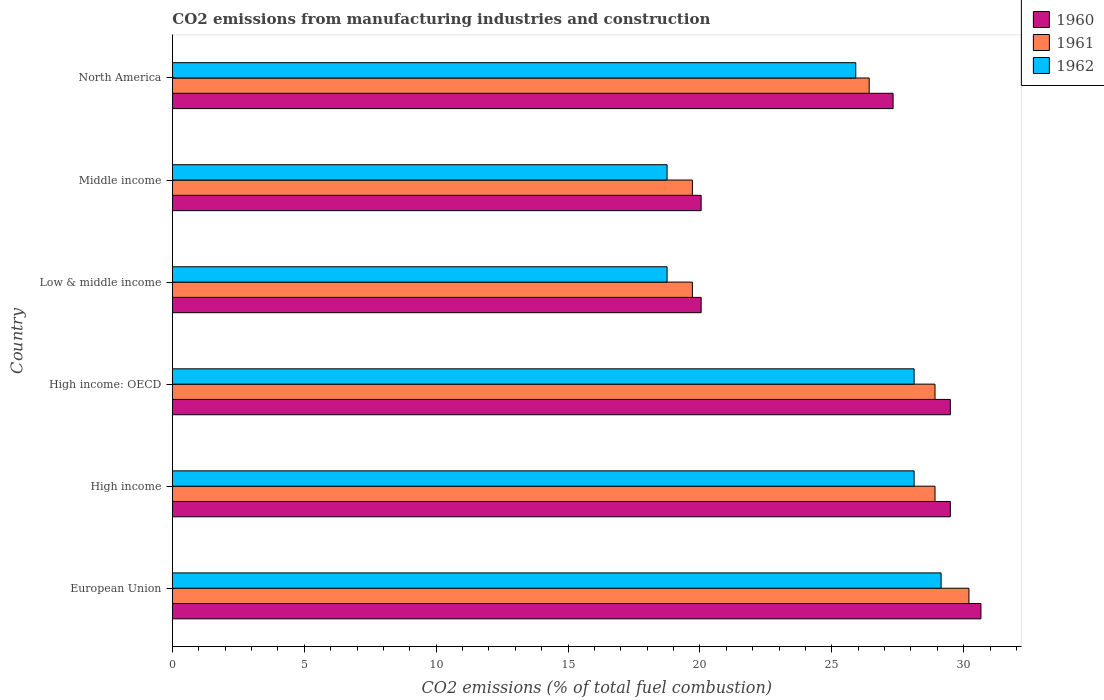How many groups of bars are there?
Provide a succinct answer. 6. Are the number of bars per tick equal to the number of legend labels?
Offer a very short reply. Yes. Are the number of bars on each tick of the Y-axis equal?
Ensure brevity in your answer.  Yes. How many bars are there on the 2nd tick from the top?
Offer a terse response. 3. How many bars are there on the 1st tick from the bottom?
Ensure brevity in your answer.  3. What is the label of the 3rd group of bars from the top?
Provide a succinct answer. Low & middle income. What is the amount of CO2 emitted in 1961 in High income: OECD?
Provide a succinct answer. 28.92. Across all countries, what is the maximum amount of CO2 emitted in 1960?
Make the answer very short. 30.66. Across all countries, what is the minimum amount of CO2 emitted in 1960?
Keep it short and to the point. 20.05. In which country was the amount of CO2 emitted in 1960 maximum?
Your response must be concise. European Union. What is the total amount of CO2 emitted in 1960 in the graph?
Your answer should be very brief. 157.07. What is the difference between the amount of CO2 emitted in 1961 in European Union and that in High income?
Provide a short and direct response. 1.29. What is the difference between the amount of CO2 emitted in 1962 in Middle income and the amount of CO2 emitted in 1961 in Low & middle income?
Offer a very short reply. -0.96. What is the average amount of CO2 emitted in 1962 per country?
Provide a succinct answer. 24.8. What is the difference between the amount of CO2 emitted in 1961 and amount of CO2 emitted in 1960 in Middle income?
Provide a short and direct response. -0.33. In how many countries, is the amount of CO2 emitted in 1960 greater than 4 %?
Ensure brevity in your answer.  6. What is the ratio of the amount of CO2 emitted in 1961 in High income: OECD to that in Low & middle income?
Make the answer very short. 1.47. Is the amount of CO2 emitted in 1961 in High income less than that in High income: OECD?
Your answer should be very brief. No. What is the difference between the highest and the second highest amount of CO2 emitted in 1962?
Give a very brief answer. 1.02. What is the difference between the highest and the lowest amount of CO2 emitted in 1960?
Offer a terse response. 10.61. Are all the bars in the graph horizontal?
Provide a short and direct response. Yes. Are the values on the major ticks of X-axis written in scientific E-notation?
Offer a very short reply. No. Does the graph contain any zero values?
Ensure brevity in your answer.  No. Does the graph contain grids?
Give a very brief answer. No. What is the title of the graph?
Make the answer very short. CO2 emissions from manufacturing industries and construction. What is the label or title of the X-axis?
Keep it short and to the point. CO2 emissions (% of total fuel combustion). What is the label or title of the Y-axis?
Your answer should be compact. Country. What is the CO2 emissions (% of total fuel combustion) of 1960 in European Union?
Keep it short and to the point. 30.66. What is the CO2 emissions (% of total fuel combustion) of 1961 in European Union?
Your answer should be compact. 30.2. What is the CO2 emissions (% of total fuel combustion) of 1962 in European Union?
Keep it short and to the point. 29.15. What is the CO2 emissions (% of total fuel combustion) of 1960 in High income?
Make the answer very short. 29.5. What is the CO2 emissions (% of total fuel combustion) in 1961 in High income?
Provide a short and direct response. 28.92. What is the CO2 emissions (% of total fuel combustion) of 1962 in High income?
Provide a short and direct response. 28.12. What is the CO2 emissions (% of total fuel combustion) in 1960 in High income: OECD?
Ensure brevity in your answer.  29.5. What is the CO2 emissions (% of total fuel combustion) of 1961 in High income: OECD?
Provide a short and direct response. 28.92. What is the CO2 emissions (% of total fuel combustion) of 1962 in High income: OECD?
Your answer should be compact. 28.12. What is the CO2 emissions (% of total fuel combustion) of 1960 in Low & middle income?
Give a very brief answer. 20.05. What is the CO2 emissions (% of total fuel combustion) of 1961 in Low & middle income?
Offer a terse response. 19.72. What is the CO2 emissions (% of total fuel combustion) in 1962 in Low & middle income?
Give a very brief answer. 18.76. What is the CO2 emissions (% of total fuel combustion) of 1960 in Middle income?
Provide a succinct answer. 20.05. What is the CO2 emissions (% of total fuel combustion) in 1961 in Middle income?
Provide a succinct answer. 19.72. What is the CO2 emissions (% of total fuel combustion) in 1962 in Middle income?
Your answer should be very brief. 18.76. What is the CO2 emissions (% of total fuel combustion) of 1960 in North America?
Offer a very short reply. 27.33. What is the CO2 emissions (% of total fuel combustion) of 1961 in North America?
Your response must be concise. 26.42. What is the CO2 emissions (% of total fuel combustion) in 1962 in North America?
Offer a terse response. 25.91. Across all countries, what is the maximum CO2 emissions (% of total fuel combustion) in 1960?
Your response must be concise. 30.66. Across all countries, what is the maximum CO2 emissions (% of total fuel combustion) in 1961?
Provide a succinct answer. 30.2. Across all countries, what is the maximum CO2 emissions (% of total fuel combustion) in 1962?
Your answer should be very brief. 29.15. Across all countries, what is the minimum CO2 emissions (% of total fuel combustion) in 1960?
Provide a succinct answer. 20.05. Across all countries, what is the minimum CO2 emissions (% of total fuel combustion) in 1961?
Keep it short and to the point. 19.72. Across all countries, what is the minimum CO2 emissions (% of total fuel combustion) of 1962?
Ensure brevity in your answer.  18.76. What is the total CO2 emissions (% of total fuel combustion) of 1960 in the graph?
Provide a short and direct response. 157.07. What is the total CO2 emissions (% of total fuel combustion) in 1961 in the graph?
Provide a short and direct response. 153.88. What is the total CO2 emissions (% of total fuel combustion) in 1962 in the graph?
Your response must be concise. 148.82. What is the difference between the CO2 emissions (% of total fuel combustion) of 1960 in European Union and that in High income?
Provide a short and direct response. 1.16. What is the difference between the CO2 emissions (% of total fuel combustion) in 1961 in European Union and that in High income?
Make the answer very short. 1.29. What is the difference between the CO2 emissions (% of total fuel combustion) in 1962 in European Union and that in High income?
Give a very brief answer. 1.02. What is the difference between the CO2 emissions (% of total fuel combustion) in 1960 in European Union and that in High income: OECD?
Make the answer very short. 1.16. What is the difference between the CO2 emissions (% of total fuel combustion) in 1961 in European Union and that in High income: OECD?
Keep it short and to the point. 1.29. What is the difference between the CO2 emissions (% of total fuel combustion) in 1962 in European Union and that in High income: OECD?
Your answer should be very brief. 1.02. What is the difference between the CO2 emissions (% of total fuel combustion) in 1960 in European Union and that in Low & middle income?
Offer a terse response. 10.61. What is the difference between the CO2 emissions (% of total fuel combustion) of 1961 in European Union and that in Low & middle income?
Your response must be concise. 10.48. What is the difference between the CO2 emissions (% of total fuel combustion) in 1962 in European Union and that in Low & middle income?
Ensure brevity in your answer.  10.39. What is the difference between the CO2 emissions (% of total fuel combustion) in 1960 in European Union and that in Middle income?
Your response must be concise. 10.61. What is the difference between the CO2 emissions (% of total fuel combustion) of 1961 in European Union and that in Middle income?
Your response must be concise. 10.48. What is the difference between the CO2 emissions (% of total fuel combustion) of 1962 in European Union and that in Middle income?
Your response must be concise. 10.39. What is the difference between the CO2 emissions (% of total fuel combustion) in 1960 in European Union and that in North America?
Offer a very short reply. 3.33. What is the difference between the CO2 emissions (% of total fuel combustion) in 1961 in European Union and that in North America?
Your response must be concise. 3.78. What is the difference between the CO2 emissions (% of total fuel combustion) of 1962 in European Union and that in North America?
Make the answer very short. 3.24. What is the difference between the CO2 emissions (% of total fuel combustion) of 1961 in High income and that in High income: OECD?
Give a very brief answer. 0. What is the difference between the CO2 emissions (% of total fuel combustion) in 1960 in High income and that in Low & middle income?
Your response must be concise. 9.45. What is the difference between the CO2 emissions (% of total fuel combustion) in 1961 in High income and that in Low & middle income?
Your answer should be very brief. 9.2. What is the difference between the CO2 emissions (% of total fuel combustion) in 1962 in High income and that in Low & middle income?
Your answer should be compact. 9.37. What is the difference between the CO2 emissions (% of total fuel combustion) of 1960 in High income and that in Middle income?
Keep it short and to the point. 9.45. What is the difference between the CO2 emissions (% of total fuel combustion) in 1961 in High income and that in Middle income?
Your answer should be very brief. 9.2. What is the difference between the CO2 emissions (% of total fuel combustion) of 1962 in High income and that in Middle income?
Your answer should be very brief. 9.37. What is the difference between the CO2 emissions (% of total fuel combustion) of 1960 in High income and that in North America?
Make the answer very short. 2.17. What is the difference between the CO2 emissions (% of total fuel combustion) of 1961 in High income and that in North America?
Your answer should be very brief. 2.5. What is the difference between the CO2 emissions (% of total fuel combustion) of 1962 in High income and that in North America?
Give a very brief answer. 2.21. What is the difference between the CO2 emissions (% of total fuel combustion) of 1960 in High income: OECD and that in Low & middle income?
Provide a succinct answer. 9.45. What is the difference between the CO2 emissions (% of total fuel combustion) of 1961 in High income: OECD and that in Low & middle income?
Make the answer very short. 9.2. What is the difference between the CO2 emissions (% of total fuel combustion) in 1962 in High income: OECD and that in Low & middle income?
Your answer should be very brief. 9.37. What is the difference between the CO2 emissions (% of total fuel combustion) of 1960 in High income: OECD and that in Middle income?
Provide a succinct answer. 9.45. What is the difference between the CO2 emissions (% of total fuel combustion) of 1961 in High income: OECD and that in Middle income?
Ensure brevity in your answer.  9.2. What is the difference between the CO2 emissions (% of total fuel combustion) of 1962 in High income: OECD and that in Middle income?
Make the answer very short. 9.37. What is the difference between the CO2 emissions (% of total fuel combustion) in 1960 in High income: OECD and that in North America?
Offer a very short reply. 2.17. What is the difference between the CO2 emissions (% of total fuel combustion) of 1961 in High income: OECD and that in North America?
Provide a short and direct response. 2.5. What is the difference between the CO2 emissions (% of total fuel combustion) of 1962 in High income: OECD and that in North America?
Make the answer very short. 2.21. What is the difference between the CO2 emissions (% of total fuel combustion) in 1960 in Low & middle income and that in Middle income?
Ensure brevity in your answer.  0. What is the difference between the CO2 emissions (% of total fuel combustion) of 1960 in Low & middle income and that in North America?
Provide a succinct answer. -7.28. What is the difference between the CO2 emissions (% of total fuel combustion) of 1961 in Low & middle income and that in North America?
Provide a short and direct response. -6.7. What is the difference between the CO2 emissions (% of total fuel combustion) of 1962 in Low & middle income and that in North America?
Your response must be concise. -7.15. What is the difference between the CO2 emissions (% of total fuel combustion) in 1960 in Middle income and that in North America?
Offer a very short reply. -7.28. What is the difference between the CO2 emissions (% of total fuel combustion) in 1961 in Middle income and that in North America?
Offer a very short reply. -6.7. What is the difference between the CO2 emissions (% of total fuel combustion) of 1962 in Middle income and that in North America?
Keep it short and to the point. -7.15. What is the difference between the CO2 emissions (% of total fuel combustion) of 1960 in European Union and the CO2 emissions (% of total fuel combustion) of 1961 in High income?
Offer a terse response. 1.74. What is the difference between the CO2 emissions (% of total fuel combustion) in 1960 in European Union and the CO2 emissions (% of total fuel combustion) in 1962 in High income?
Offer a very short reply. 2.53. What is the difference between the CO2 emissions (% of total fuel combustion) in 1961 in European Union and the CO2 emissions (% of total fuel combustion) in 1962 in High income?
Ensure brevity in your answer.  2.08. What is the difference between the CO2 emissions (% of total fuel combustion) in 1960 in European Union and the CO2 emissions (% of total fuel combustion) in 1961 in High income: OECD?
Make the answer very short. 1.74. What is the difference between the CO2 emissions (% of total fuel combustion) of 1960 in European Union and the CO2 emissions (% of total fuel combustion) of 1962 in High income: OECD?
Give a very brief answer. 2.53. What is the difference between the CO2 emissions (% of total fuel combustion) in 1961 in European Union and the CO2 emissions (% of total fuel combustion) in 1962 in High income: OECD?
Offer a terse response. 2.08. What is the difference between the CO2 emissions (% of total fuel combustion) of 1960 in European Union and the CO2 emissions (% of total fuel combustion) of 1961 in Low & middle income?
Your answer should be compact. 10.94. What is the difference between the CO2 emissions (% of total fuel combustion) of 1960 in European Union and the CO2 emissions (% of total fuel combustion) of 1962 in Low & middle income?
Make the answer very short. 11.9. What is the difference between the CO2 emissions (% of total fuel combustion) in 1961 in European Union and the CO2 emissions (% of total fuel combustion) in 1962 in Low & middle income?
Offer a very short reply. 11.44. What is the difference between the CO2 emissions (% of total fuel combustion) of 1960 in European Union and the CO2 emissions (% of total fuel combustion) of 1961 in Middle income?
Your answer should be compact. 10.94. What is the difference between the CO2 emissions (% of total fuel combustion) in 1960 in European Union and the CO2 emissions (% of total fuel combustion) in 1962 in Middle income?
Keep it short and to the point. 11.9. What is the difference between the CO2 emissions (% of total fuel combustion) in 1961 in European Union and the CO2 emissions (% of total fuel combustion) in 1962 in Middle income?
Give a very brief answer. 11.44. What is the difference between the CO2 emissions (% of total fuel combustion) of 1960 in European Union and the CO2 emissions (% of total fuel combustion) of 1961 in North America?
Provide a succinct answer. 4.24. What is the difference between the CO2 emissions (% of total fuel combustion) in 1960 in European Union and the CO2 emissions (% of total fuel combustion) in 1962 in North America?
Your answer should be very brief. 4.75. What is the difference between the CO2 emissions (% of total fuel combustion) in 1961 in European Union and the CO2 emissions (% of total fuel combustion) in 1962 in North America?
Provide a short and direct response. 4.29. What is the difference between the CO2 emissions (% of total fuel combustion) in 1960 in High income and the CO2 emissions (% of total fuel combustion) in 1961 in High income: OECD?
Ensure brevity in your answer.  0.58. What is the difference between the CO2 emissions (% of total fuel combustion) of 1960 in High income and the CO2 emissions (% of total fuel combustion) of 1962 in High income: OECD?
Offer a very short reply. 1.37. What is the difference between the CO2 emissions (% of total fuel combustion) in 1961 in High income and the CO2 emissions (% of total fuel combustion) in 1962 in High income: OECD?
Keep it short and to the point. 0.79. What is the difference between the CO2 emissions (% of total fuel combustion) in 1960 in High income and the CO2 emissions (% of total fuel combustion) in 1961 in Low & middle income?
Offer a very short reply. 9.78. What is the difference between the CO2 emissions (% of total fuel combustion) in 1960 in High income and the CO2 emissions (% of total fuel combustion) in 1962 in Low & middle income?
Offer a terse response. 10.74. What is the difference between the CO2 emissions (% of total fuel combustion) of 1961 in High income and the CO2 emissions (% of total fuel combustion) of 1962 in Low & middle income?
Give a very brief answer. 10.16. What is the difference between the CO2 emissions (% of total fuel combustion) of 1960 in High income and the CO2 emissions (% of total fuel combustion) of 1961 in Middle income?
Provide a short and direct response. 9.78. What is the difference between the CO2 emissions (% of total fuel combustion) in 1960 in High income and the CO2 emissions (% of total fuel combustion) in 1962 in Middle income?
Keep it short and to the point. 10.74. What is the difference between the CO2 emissions (% of total fuel combustion) of 1961 in High income and the CO2 emissions (% of total fuel combustion) of 1962 in Middle income?
Make the answer very short. 10.16. What is the difference between the CO2 emissions (% of total fuel combustion) in 1960 in High income and the CO2 emissions (% of total fuel combustion) in 1961 in North America?
Your answer should be compact. 3.08. What is the difference between the CO2 emissions (% of total fuel combustion) of 1960 in High income and the CO2 emissions (% of total fuel combustion) of 1962 in North America?
Your response must be concise. 3.59. What is the difference between the CO2 emissions (% of total fuel combustion) of 1961 in High income and the CO2 emissions (% of total fuel combustion) of 1962 in North America?
Make the answer very short. 3. What is the difference between the CO2 emissions (% of total fuel combustion) in 1960 in High income: OECD and the CO2 emissions (% of total fuel combustion) in 1961 in Low & middle income?
Keep it short and to the point. 9.78. What is the difference between the CO2 emissions (% of total fuel combustion) in 1960 in High income: OECD and the CO2 emissions (% of total fuel combustion) in 1962 in Low & middle income?
Offer a very short reply. 10.74. What is the difference between the CO2 emissions (% of total fuel combustion) in 1961 in High income: OECD and the CO2 emissions (% of total fuel combustion) in 1962 in Low & middle income?
Your answer should be very brief. 10.16. What is the difference between the CO2 emissions (% of total fuel combustion) of 1960 in High income: OECD and the CO2 emissions (% of total fuel combustion) of 1961 in Middle income?
Your response must be concise. 9.78. What is the difference between the CO2 emissions (% of total fuel combustion) of 1960 in High income: OECD and the CO2 emissions (% of total fuel combustion) of 1962 in Middle income?
Ensure brevity in your answer.  10.74. What is the difference between the CO2 emissions (% of total fuel combustion) of 1961 in High income: OECD and the CO2 emissions (% of total fuel combustion) of 1962 in Middle income?
Offer a very short reply. 10.16. What is the difference between the CO2 emissions (% of total fuel combustion) in 1960 in High income: OECD and the CO2 emissions (% of total fuel combustion) in 1961 in North America?
Keep it short and to the point. 3.08. What is the difference between the CO2 emissions (% of total fuel combustion) in 1960 in High income: OECD and the CO2 emissions (% of total fuel combustion) in 1962 in North America?
Keep it short and to the point. 3.59. What is the difference between the CO2 emissions (% of total fuel combustion) in 1961 in High income: OECD and the CO2 emissions (% of total fuel combustion) in 1962 in North America?
Ensure brevity in your answer.  3. What is the difference between the CO2 emissions (% of total fuel combustion) of 1960 in Low & middle income and the CO2 emissions (% of total fuel combustion) of 1961 in Middle income?
Provide a succinct answer. 0.33. What is the difference between the CO2 emissions (% of total fuel combustion) of 1960 in Low & middle income and the CO2 emissions (% of total fuel combustion) of 1962 in Middle income?
Your answer should be compact. 1.29. What is the difference between the CO2 emissions (% of total fuel combustion) of 1961 in Low & middle income and the CO2 emissions (% of total fuel combustion) of 1962 in Middle income?
Ensure brevity in your answer.  0.96. What is the difference between the CO2 emissions (% of total fuel combustion) of 1960 in Low & middle income and the CO2 emissions (% of total fuel combustion) of 1961 in North America?
Give a very brief answer. -6.37. What is the difference between the CO2 emissions (% of total fuel combustion) of 1960 in Low & middle income and the CO2 emissions (% of total fuel combustion) of 1962 in North America?
Your answer should be compact. -5.86. What is the difference between the CO2 emissions (% of total fuel combustion) of 1961 in Low & middle income and the CO2 emissions (% of total fuel combustion) of 1962 in North America?
Provide a short and direct response. -6.19. What is the difference between the CO2 emissions (% of total fuel combustion) in 1960 in Middle income and the CO2 emissions (% of total fuel combustion) in 1961 in North America?
Give a very brief answer. -6.37. What is the difference between the CO2 emissions (% of total fuel combustion) of 1960 in Middle income and the CO2 emissions (% of total fuel combustion) of 1962 in North America?
Give a very brief answer. -5.86. What is the difference between the CO2 emissions (% of total fuel combustion) in 1961 in Middle income and the CO2 emissions (% of total fuel combustion) in 1962 in North America?
Ensure brevity in your answer.  -6.19. What is the average CO2 emissions (% of total fuel combustion) of 1960 per country?
Keep it short and to the point. 26.18. What is the average CO2 emissions (% of total fuel combustion) in 1961 per country?
Keep it short and to the point. 25.65. What is the average CO2 emissions (% of total fuel combustion) of 1962 per country?
Your response must be concise. 24.8. What is the difference between the CO2 emissions (% of total fuel combustion) in 1960 and CO2 emissions (% of total fuel combustion) in 1961 in European Union?
Make the answer very short. 0.46. What is the difference between the CO2 emissions (% of total fuel combustion) in 1960 and CO2 emissions (% of total fuel combustion) in 1962 in European Union?
Keep it short and to the point. 1.51. What is the difference between the CO2 emissions (% of total fuel combustion) of 1961 and CO2 emissions (% of total fuel combustion) of 1962 in European Union?
Make the answer very short. 1.05. What is the difference between the CO2 emissions (% of total fuel combustion) of 1960 and CO2 emissions (% of total fuel combustion) of 1961 in High income?
Provide a short and direct response. 0.58. What is the difference between the CO2 emissions (% of total fuel combustion) in 1960 and CO2 emissions (% of total fuel combustion) in 1962 in High income?
Your answer should be very brief. 1.37. What is the difference between the CO2 emissions (% of total fuel combustion) of 1961 and CO2 emissions (% of total fuel combustion) of 1962 in High income?
Your answer should be very brief. 0.79. What is the difference between the CO2 emissions (% of total fuel combustion) in 1960 and CO2 emissions (% of total fuel combustion) in 1961 in High income: OECD?
Make the answer very short. 0.58. What is the difference between the CO2 emissions (% of total fuel combustion) in 1960 and CO2 emissions (% of total fuel combustion) in 1962 in High income: OECD?
Give a very brief answer. 1.37. What is the difference between the CO2 emissions (% of total fuel combustion) of 1961 and CO2 emissions (% of total fuel combustion) of 1962 in High income: OECD?
Provide a succinct answer. 0.79. What is the difference between the CO2 emissions (% of total fuel combustion) in 1960 and CO2 emissions (% of total fuel combustion) in 1961 in Low & middle income?
Ensure brevity in your answer.  0.33. What is the difference between the CO2 emissions (% of total fuel combustion) of 1960 and CO2 emissions (% of total fuel combustion) of 1962 in Low & middle income?
Your response must be concise. 1.29. What is the difference between the CO2 emissions (% of total fuel combustion) of 1961 and CO2 emissions (% of total fuel combustion) of 1962 in Low & middle income?
Offer a terse response. 0.96. What is the difference between the CO2 emissions (% of total fuel combustion) in 1960 and CO2 emissions (% of total fuel combustion) in 1961 in Middle income?
Give a very brief answer. 0.33. What is the difference between the CO2 emissions (% of total fuel combustion) in 1960 and CO2 emissions (% of total fuel combustion) in 1962 in Middle income?
Your answer should be very brief. 1.29. What is the difference between the CO2 emissions (% of total fuel combustion) of 1961 and CO2 emissions (% of total fuel combustion) of 1962 in Middle income?
Your response must be concise. 0.96. What is the difference between the CO2 emissions (% of total fuel combustion) in 1960 and CO2 emissions (% of total fuel combustion) in 1961 in North America?
Keep it short and to the point. 0.91. What is the difference between the CO2 emissions (% of total fuel combustion) of 1960 and CO2 emissions (% of total fuel combustion) of 1962 in North America?
Make the answer very short. 1.42. What is the difference between the CO2 emissions (% of total fuel combustion) in 1961 and CO2 emissions (% of total fuel combustion) in 1962 in North America?
Provide a short and direct response. 0.51. What is the ratio of the CO2 emissions (% of total fuel combustion) of 1960 in European Union to that in High income?
Keep it short and to the point. 1.04. What is the ratio of the CO2 emissions (% of total fuel combustion) in 1961 in European Union to that in High income?
Give a very brief answer. 1.04. What is the ratio of the CO2 emissions (% of total fuel combustion) of 1962 in European Union to that in High income?
Keep it short and to the point. 1.04. What is the ratio of the CO2 emissions (% of total fuel combustion) of 1960 in European Union to that in High income: OECD?
Your answer should be very brief. 1.04. What is the ratio of the CO2 emissions (% of total fuel combustion) of 1961 in European Union to that in High income: OECD?
Your answer should be very brief. 1.04. What is the ratio of the CO2 emissions (% of total fuel combustion) in 1962 in European Union to that in High income: OECD?
Offer a terse response. 1.04. What is the ratio of the CO2 emissions (% of total fuel combustion) of 1960 in European Union to that in Low & middle income?
Make the answer very short. 1.53. What is the ratio of the CO2 emissions (% of total fuel combustion) in 1961 in European Union to that in Low & middle income?
Your answer should be compact. 1.53. What is the ratio of the CO2 emissions (% of total fuel combustion) of 1962 in European Union to that in Low & middle income?
Keep it short and to the point. 1.55. What is the ratio of the CO2 emissions (% of total fuel combustion) of 1960 in European Union to that in Middle income?
Offer a terse response. 1.53. What is the ratio of the CO2 emissions (% of total fuel combustion) in 1961 in European Union to that in Middle income?
Your response must be concise. 1.53. What is the ratio of the CO2 emissions (% of total fuel combustion) of 1962 in European Union to that in Middle income?
Provide a succinct answer. 1.55. What is the ratio of the CO2 emissions (% of total fuel combustion) of 1960 in European Union to that in North America?
Make the answer very short. 1.12. What is the ratio of the CO2 emissions (% of total fuel combustion) of 1961 in European Union to that in North America?
Give a very brief answer. 1.14. What is the ratio of the CO2 emissions (% of total fuel combustion) of 1962 in European Union to that in North America?
Offer a terse response. 1.12. What is the ratio of the CO2 emissions (% of total fuel combustion) in 1961 in High income to that in High income: OECD?
Give a very brief answer. 1. What is the ratio of the CO2 emissions (% of total fuel combustion) in 1960 in High income to that in Low & middle income?
Provide a succinct answer. 1.47. What is the ratio of the CO2 emissions (% of total fuel combustion) in 1961 in High income to that in Low & middle income?
Offer a terse response. 1.47. What is the ratio of the CO2 emissions (% of total fuel combustion) in 1962 in High income to that in Low & middle income?
Keep it short and to the point. 1.5. What is the ratio of the CO2 emissions (% of total fuel combustion) in 1960 in High income to that in Middle income?
Provide a succinct answer. 1.47. What is the ratio of the CO2 emissions (% of total fuel combustion) in 1961 in High income to that in Middle income?
Keep it short and to the point. 1.47. What is the ratio of the CO2 emissions (% of total fuel combustion) in 1962 in High income to that in Middle income?
Offer a very short reply. 1.5. What is the ratio of the CO2 emissions (% of total fuel combustion) in 1960 in High income to that in North America?
Keep it short and to the point. 1.08. What is the ratio of the CO2 emissions (% of total fuel combustion) in 1961 in High income to that in North America?
Provide a succinct answer. 1.09. What is the ratio of the CO2 emissions (% of total fuel combustion) in 1962 in High income to that in North America?
Ensure brevity in your answer.  1.09. What is the ratio of the CO2 emissions (% of total fuel combustion) in 1960 in High income: OECD to that in Low & middle income?
Make the answer very short. 1.47. What is the ratio of the CO2 emissions (% of total fuel combustion) of 1961 in High income: OECD to that in Low & middle income?
Your answer should be very brief. 1.47. What is the ratio of the CO2 emissions (% of total fuel combustion) of 1962 in High income: OECD to that in Low & middle income?
Your answer should be compact. 1.5. What is the ratio of the CO2 emissions (% of total fuel combustion) in 1960 in High income: OECD to that in Middle income?
Your answer should be compact. 1.47. What is the ratio of the CO2 emissions (% of total fuel combustion) in 1961 in High income: OECD to that in Middle income?
Your answer should be very brief. 1.47. What is the ratio of the CO2 emissions (% of total fuel combustion) of 1962 in High income: OECD to that in Middle income?
Keep it short and to the point. 1.5. What is the ratio of the CO2 emissions (% of total fuel combustion) of 1960 in High income: OECD to that in North America?
Your answer should be compact. 1.08. What is the ratio of the CO2 emissions (% of total fuel combustion) in 1961 in High income: OECD to that in North America?
Provide a succinct answer. 1.09. What is the ratio of the CO2 emissions (% of total fuel combustion) in 1962 in High income: OECD to that in North America?
Provide a succinct answer. 1.09. What is the ratio of the CO2 emissions (% of total fuel combustion) of 1960 in Low & middle income to that in Middle income?
Provide a succinct answer. 1. What is the ratio of the CO2 emissions (% of total fuel combustion) of 1960 in Low & middle income to that in North America?
Make the answer very short. 0.73. What is the ratio of the CO2 emissions (% of total fuel combustion) of 1961 in Low & middle income to that in North America?
Keep it short and to the point. 0.75. What is the ratio of the CO2 emissions (% of total fuel combustion) of 1962 in Low & middle income to that in North America?
Ensure brevity in your answer.  0.72. What is the ratio of the CO2 emissions (% of total fuel combustion) of 1960 in Middle income to that in North America?
Provide a short and direct response. 0.73. What is the ratio of the CO2 emissions (% of total fuel combustion) of 1961 in Middle income to that in North America?
Ensure brevity in your answer.  0.75. What is the ratio of the CO2 emissions (% of total fuel combustion) in 1962 in Middle income to that in North America?
Provide a short and direct response. 0.72. What is the difference between the highest and the second highest CO2 emissions (% of total fuel combustion) of 1960?
Your answer should be very brief. 1.16. What is the difference between the highest and the second highest CO2 emissions (% of total fuel combustion) of 1961?
Keep it short and to the point. 1.29. What is the difference between the highest and the second highest CO2 emissions (% of total fuel combustion) of 1962?
Provide a succinct answer. 1.02. What is the difference between the highest and the lowest CO2 emissions (% of total fuel combustion) of 1960?
Provide a short and direct response. 10.61. What is the difference between the highest and the lowest CO2 emissions (% of total fuel combustion) in 1961?
Make the answer very short. 10.48. What is the difference between the highest and the lowest CO2 emissions (% of total fuel combustion) in 1962?
Keep it short and to the point. 10.39. 